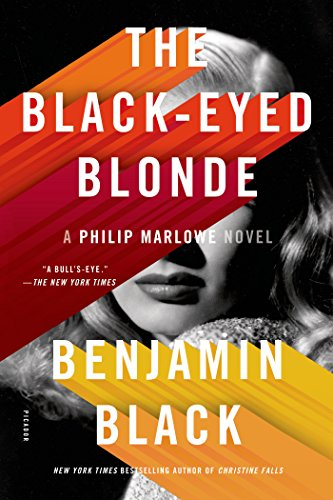What is the title of this book? The complete title of the book is 'The Black-Eyed Blonde: A Philip Marlowe Novel,' which is part of the Philip Marlowe Series, reviving the iconic private detective character created by Raymond Chandler. 